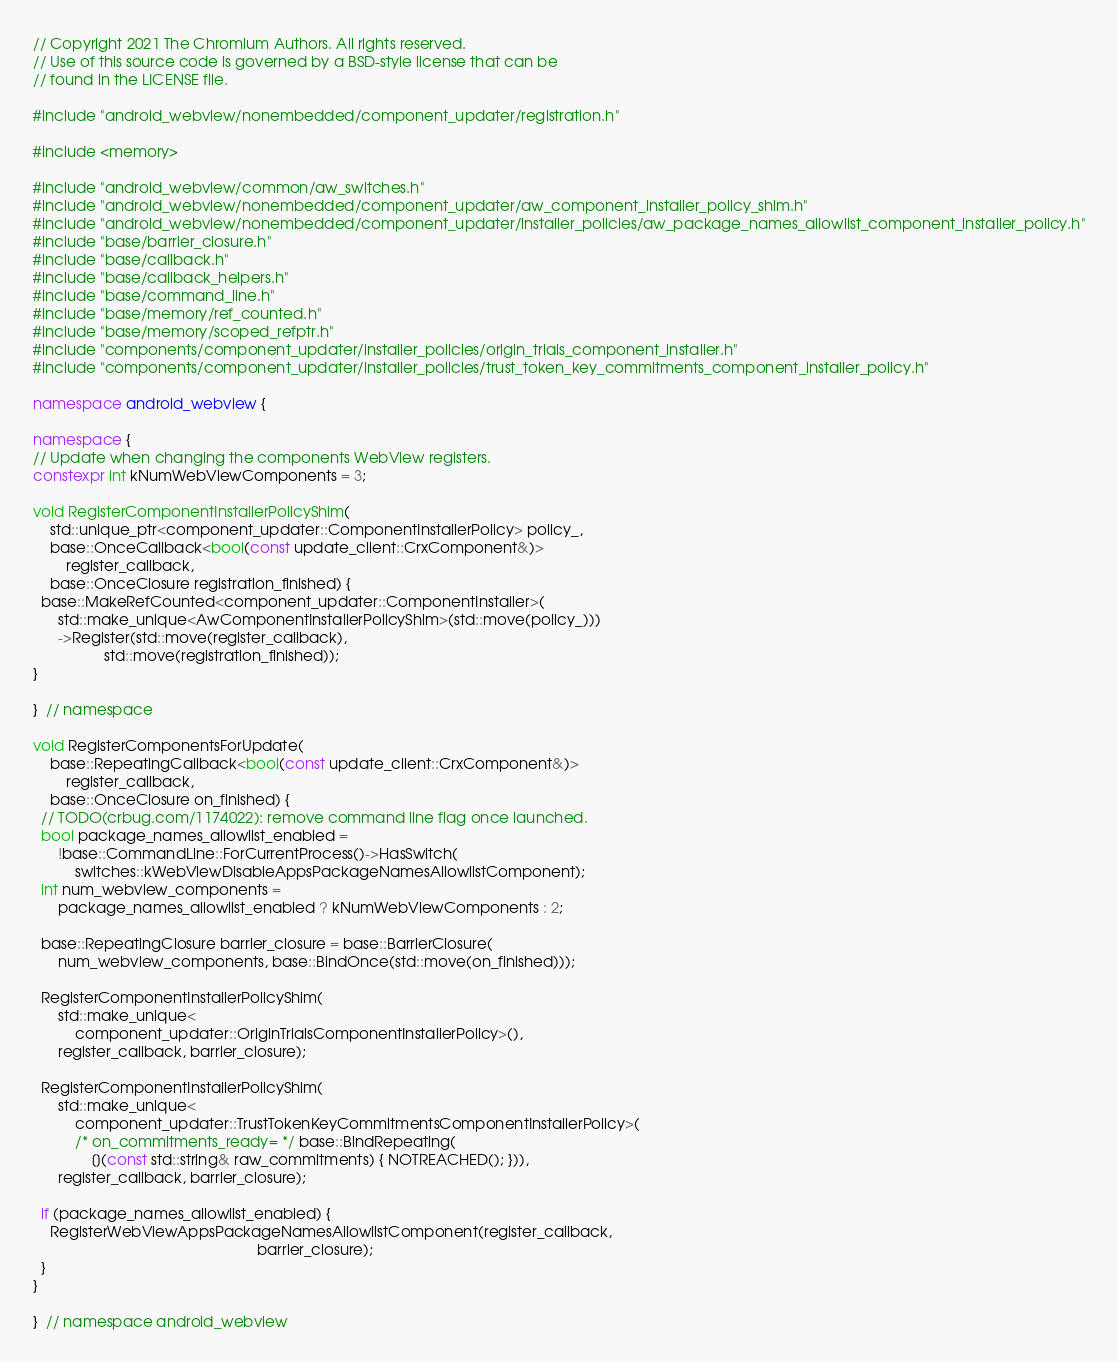Convert code to text. <code><loc_0><loc_0><loc_500><loc_500><_C++_>// Copyright 2021 The Chromium Authors. All rights reserved.
// Use of this source code is governed by a BSD-style license that can be
// found in the LICENSE file.

#include "android_webview/nonembedded/component_updater/registration.h"

#include <memory>

#include "android_webview/common/aw_switches.h"
#include "android_webview/nonembedded/component_updater/aw_component_installer_policy_shim.h"
#include "android_webview/nonembedded/component_updater/installer_policies/aw_package_names_allowlist_component_installer_policy.h"
#include "base/barrier_closure.h"
#include "base/callback.h"
#include "base/callback_helpers.h"
#include "base/command_line.h"
#include "base/memory/ref_counted.h"
#include "base/memory/scoped_refptr.h"
#include "components/component_updater/installer_policies/origin_trials_component_installer.h"
#include "components/component_updater/installer_policies/trust_token_key_commitments_component_installer_policy.h"

namespace android_webview {

namespace {
// Update when changing the components WebView registers.
constexpr int kNumWebViewComponents = 3;

void RegisterComponentInstallerPolicyShim(
    std::unique_ptr<component_updater::ComponentInstallerPolicy> policy_,
    base::OnceCallback<bool(const update_client::CrxComponent&)>
        register_callback,
    base::OnceClosure registration_finished) {
  base::MakeRefCounted<component_updater::ComponentInstaller>(
      std::make_unique<AwComponentInstallerPolicyShim>(std::move(policy_)))
      ->Register(std::move(register_callback),
                 std::move(registration_finished));
}

}  // namespace

void RegisterComponentsForUpdate(
    base::RepeatingCallback<bool(const update_client::CrxComponent&)>
        register_callback,
    base::OnceClosure on_finished) {
  // TODO(crbug.com/1174022): remove command line flag once launched.
  bool package_names_allowlist_enabled =
      !base::CommandLine::ForCurrentProcess()->HasSwitch(
          switches::kWebViewDisableAppsPackageNamesAllowlistComponent);
  int num_webview_components =
      package_names_allowlist_enabled ? kNumWebViewComponents : 2;

  base::RepeatingClosure barrier_closure = base::BarrierClosure(
      num_webview_components, base::BindOnce(std::move(on_finished)));

  RegisterComponentInstallerPolicyShim(
      std::make_unique<
          component_updater::OriginTrialsComponentInstallerPolicy>(),
      register_callback, barrier_closure);

  RegisterComponentInstallerPolicyShim(
      std::make_unique<
          component_updater::TrustTokenKeyCommitmentsComponentInstallerPolicy>(
          /* on_commitments_ready= */ base::BindRepeating(
              [](const std::string& raw_commitments) { NOTREACHED(); })),
      register_callback, barrier_closure);

  if (package_names_allowlist_enabled) {
    RegisterWebViewAppsPackageNamesAllowlistComponent(register_callback,
                                                      barrier_closure);
  }
}

}  // namespace android_webview
</code> 